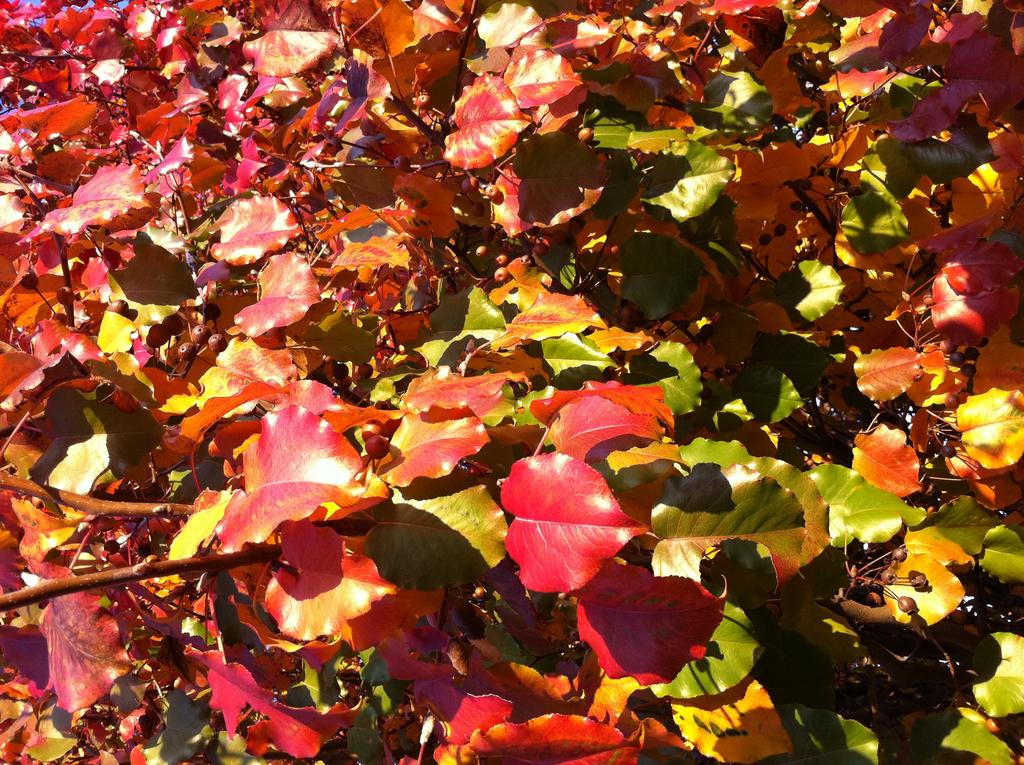What type of vegetation can be seen in the image? There are leaves in the image. How many houses can be seen crossing the bridge in the image? There are no houses or bridges present in the image; it only features leaves. 